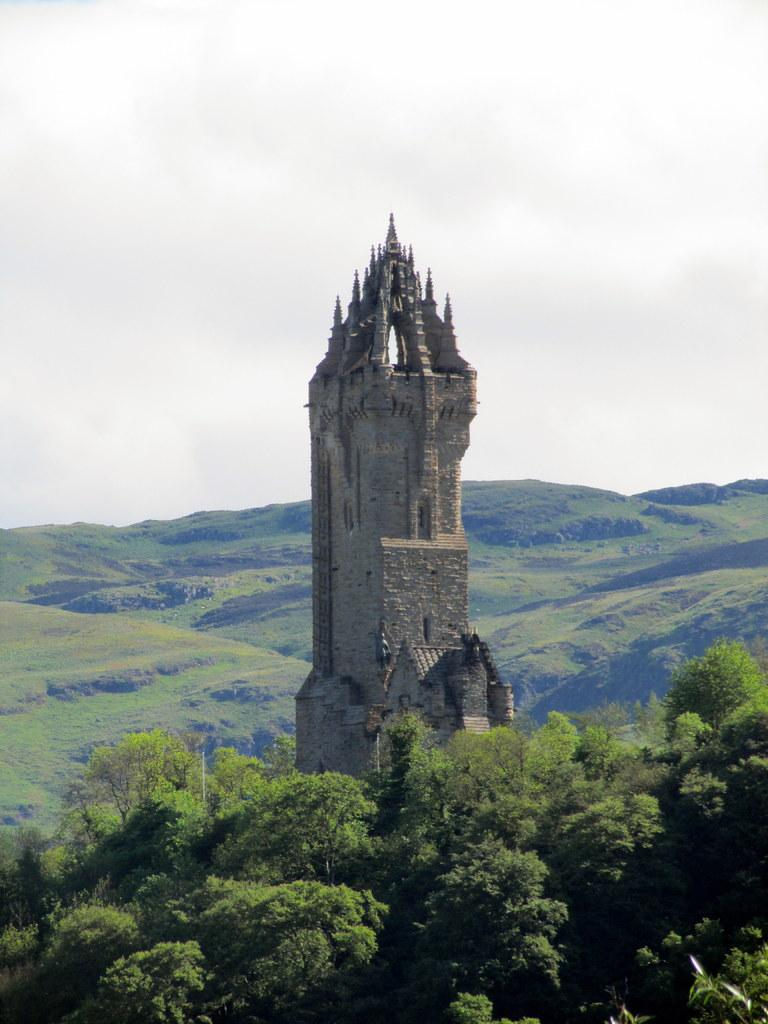What is the main structure in the middle of the image? The Wallace monument is in the middle of the image. What type of natural features can be seen in the background? There are mountains visible in the image. What type of vegetation is present on the ground in the image? There are trees on the ground in the image. What type of vegetation is present on the mountains in the image? There is grass on the mountains in the image. What is visible at the top of the image? The sky is visible at the top of the image. What thought is the Wallace monument having in the image? The Wallace monument is an inanimate object and does not have thoughts. --- 